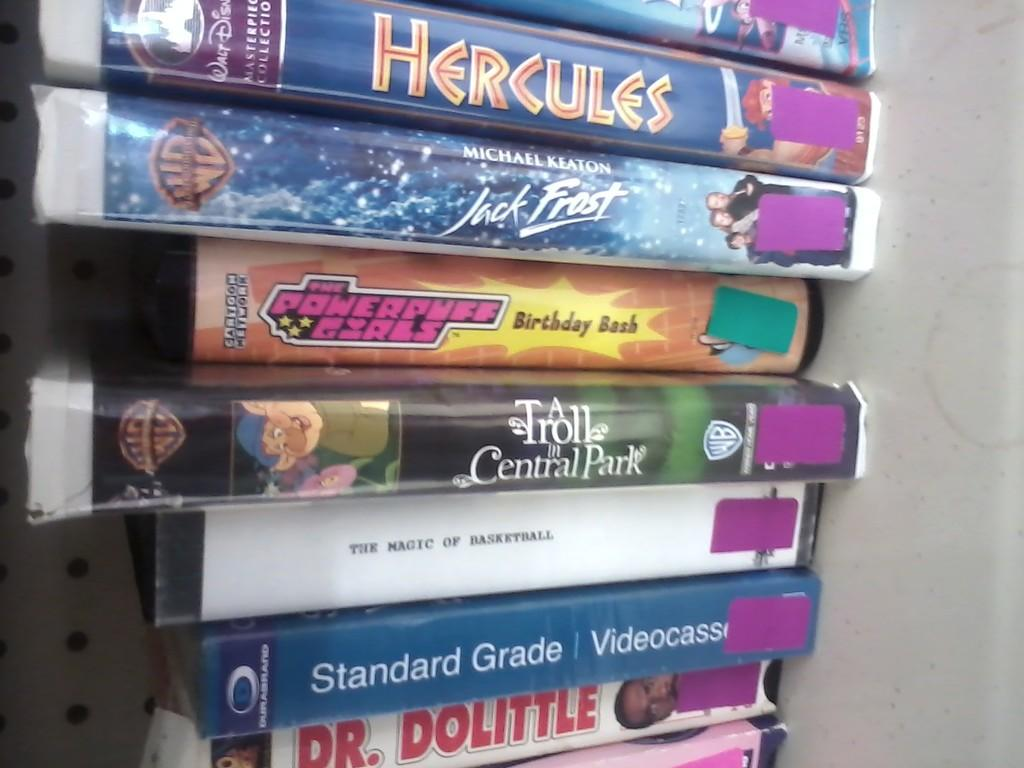<image>
Give a short and clear explanation of the subsequent image. A stack of DVDs that are mostly cartoon such as Hercules and The Powerpuff Girls. 